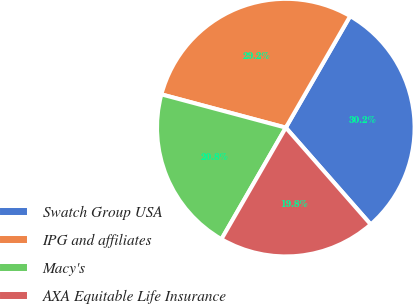Convert chart to OTSL. <chart><loc_0><loc_0><loc_500><loc_500><pie_chart><fcel>Swatch Group USA<fcel>IPG and affiliates<fcel>Macy's<fcel>AXA Equitable Life Insurance<nl><fcel>30.21%<fcel>29.17%<fcel>20.83%<fcel>19.79%<nl></chart> 